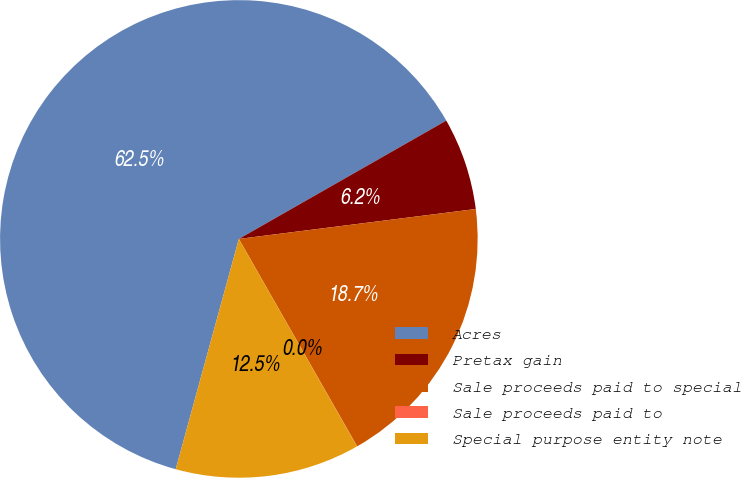Convert chart to OTSL. <chart><loc_0><loc_0><loc_500><loc_500><pie_chart><fcel>Acres<fcel>Pretax gain<fcel>Sale proceeds paid to special<fcel>Sale proceeds paid to<fcel>Special purpose entity note<nl><fcel>62.49%<fcel>6.25%<fcel>18.75%<fcel>0.01%<fcel>12.5%<nl></chart> 